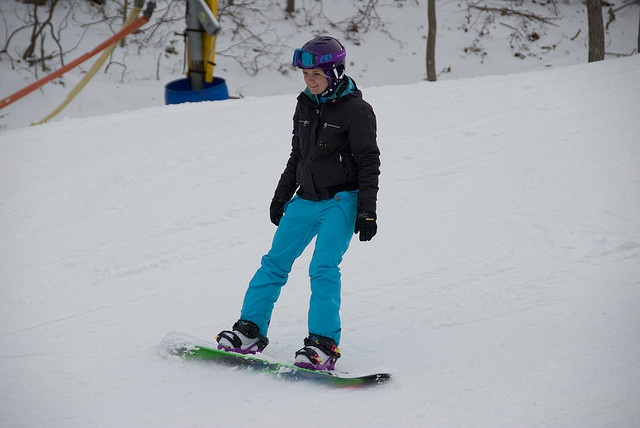Describe the objects in this image and their specific colors. I can see people in gray, black, teal, blue, and darkgray tones and snowboard in gray, darkgray, darkgreen, and teal tones in this image. 